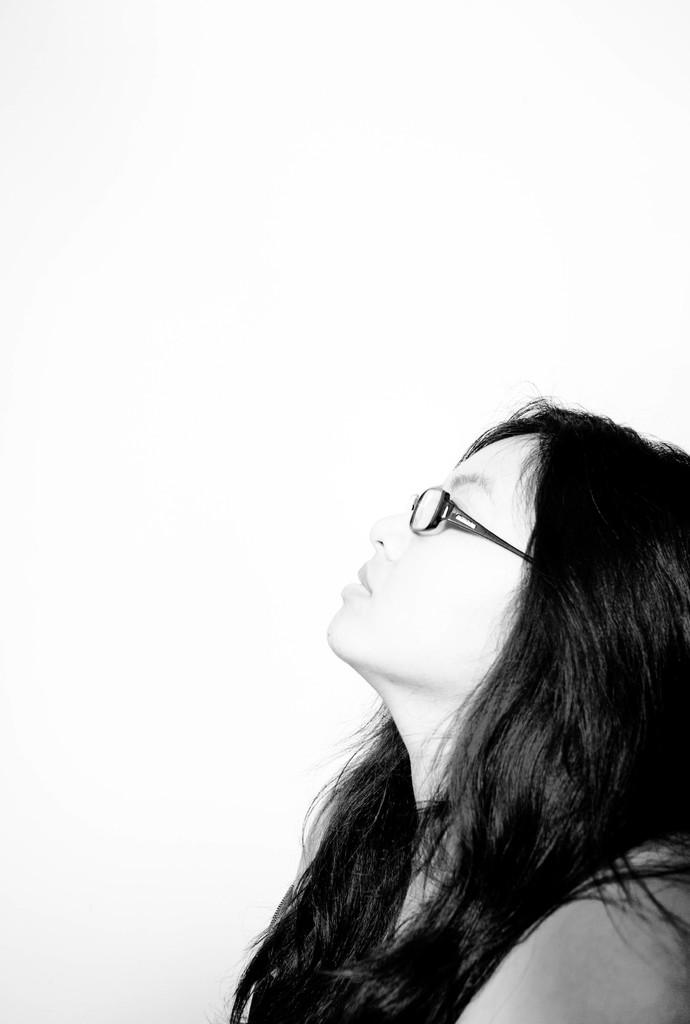Who is the main subject in the image? There is a girl in the image. What is the girl wearing in the image? The girl is wearing specs in the image. What is the color of the background in the image? The background of the image is white. What type of drink is the girl holding in the image? There is no drink present in the image; the girl is not holding anything. Is there any smoke visible in the image? There is no smoke present in the image. 